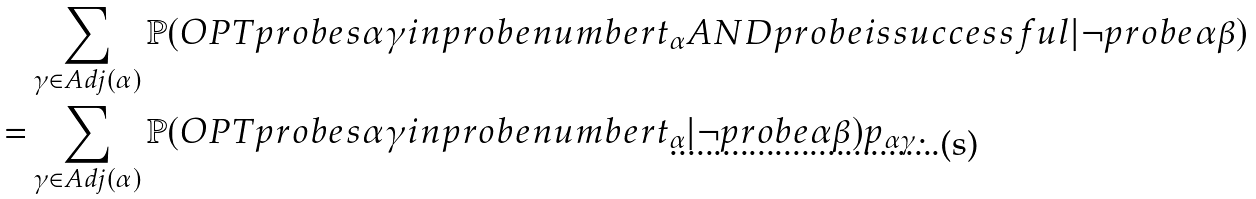Convert formula to latex. <formula><loc_0><loc_0><loc_500><loc_500>& \sum _ { \gamma \in A d j ( \alpha ) } \mathbb { P } ( O P T p r o b e s \alpha \gamma i n p r o b e n u m b e r t _ { \alpha } A N D p r o b e i s s u c c e s s f u l | \neg p r o b e \alpha \beta ) \\ = & \sum _ { \gamma \in A d j ( \alpha ) } \mathbb { P } ( O P T p r o b e s \alpha \gamma i n p r o b e n u m b e r t _ { \alpha } | \neg p r o b e \alpha \beta ) p _ { \alpha \gamma } .</formula> 